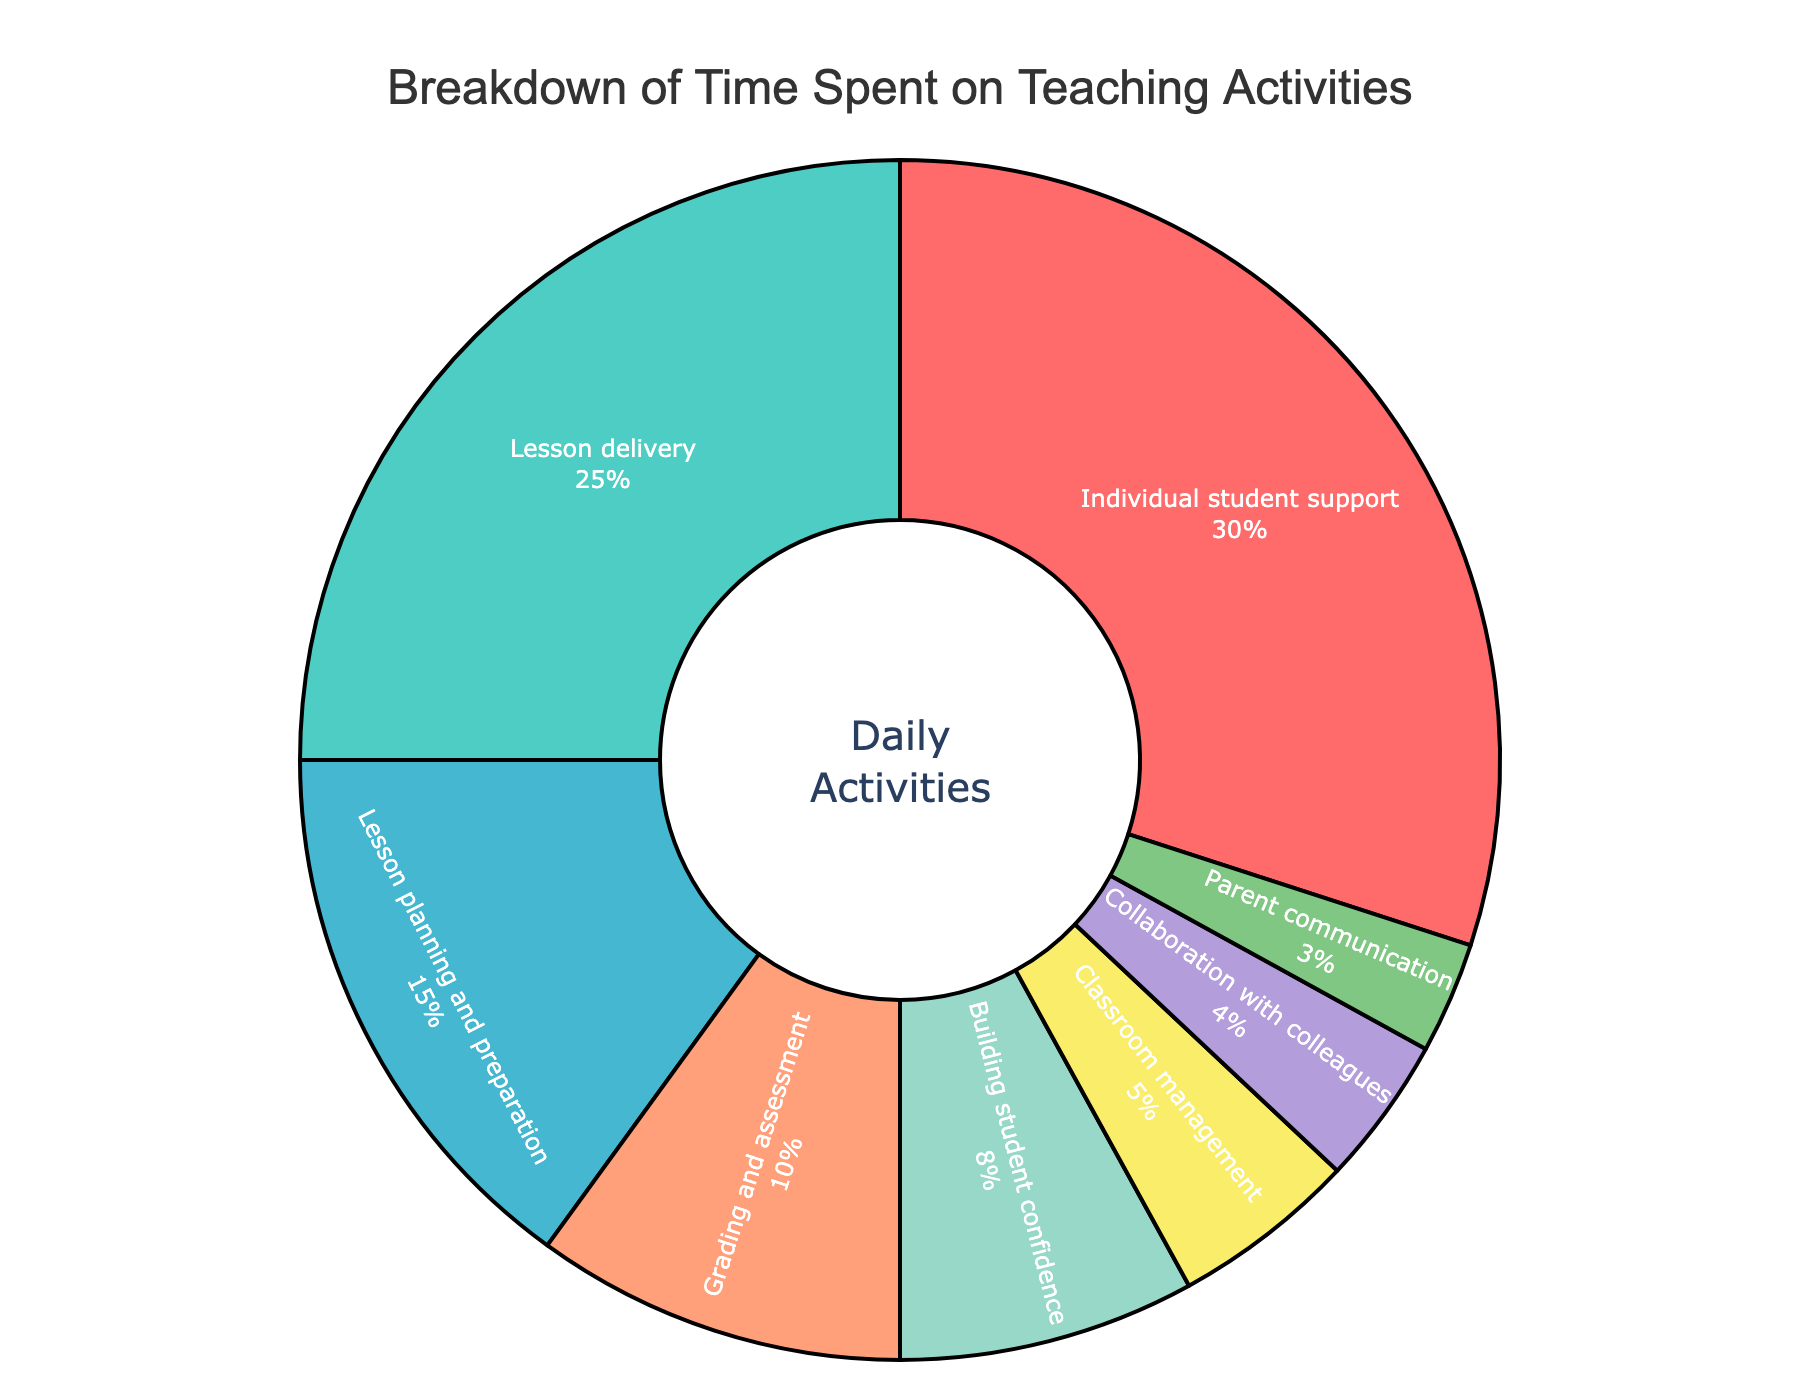what percentage of the time is spent on collaboration with colleagues? The pie chart shows a labeled percentage for each activity. The percentage for "Collaboration with colleagues" is labeled as 4%.
Answer: 4% which activity receives the most time? The pie chart shows different activities with their corresponding percentages. The largest slice and highest percentage is for "Individual student support" at 30%.
Answer: Individual student support how much more time is spent on lesson delivery compared to classroom management? The percentage for "Lesson delivery" is 25% and for "Classroom management" is 5%. Subtract the percentage for "Classroom management" from "Lesson delivery": 25% - 5% = 20%.
Answer: 20% which activity takes up the least time, and what percentage of the day is it? By observing the pie chart, the smallest slice corresponds to "Parent communication" with a percentage of 3%.
Answer: Parent communication, 3% what is the combined percentage of time spent on grading and assessment and parent communication? The percentage for "Grading and assessment" is 10% and for "Parent communication" is 3%. Add these two percentages together: 10% + 3% = 13%.
Answer: 13% which is more time-consuming, building student confidence or lesson planning and preparation? The pie chart shows that "Building student confidence" is 8% and "Lesson planning and preparation" is 15%. Compare the two percentages, and lesson planning and preparation have a higher percentage.
Answer: Lesson planning and preparation is the time spent on classroom management greater than the time spent on parent communication? The percentage for "Classroom management" is 5% and for "Parent communication" is 3%. Since 5% is greater than 3%, more time is spent on classroom management.
Answer: Yes what percentage of the total time is dedicated to combined individual student support and lesson delivery? The percentage for "Individual student support" is 30% and for "Lesson delivery" is 25%. Add these two percentages together: 30% + 25% = 55%.
Answer: 55% what is the average percentage of time spent on classroom management, collaboration with colleagues, and parent communication? The percentages are 5% for "Classroom management", 4% for "Collaboration with colleagues", and 3% for "Parent communication". Add these together and divide by 3: (5% + 4% + 3%) / 3 = 12% / 3 = 4%.
Answer: 4% how does the time spent on lesson planning and preparation compare to collaboration with colleagues visually in terms of slice size and position? Visually, the slice for "Lesson planning and preparation" is larger than that for "Collaboration with colleagues". The "Lesson planning and preparation" slice occupies a larger central area compared to the smaller "Collaboration with colleagues" slice.
Answer: Lesson planning and preparation slice is larger 